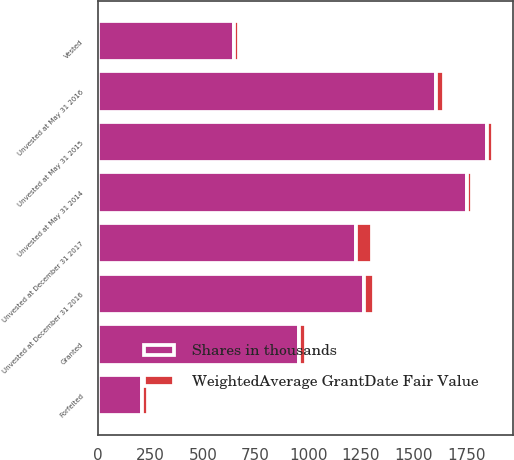Convert chart. <chart><loc_0><loc_0><loc_500><loc_500><stacked_bar_chart><ecel><fcel>Unvested at May 31 2014<fcel>Granted<fcel>Vested<fcel>Forfeited<fcel>Unvested at May 31 2015<fcel>Unvested at May 31 2016<fcel>Unvested at December 31 2016<fcel>Unvested at December 31 2017<nl><fcel>Shares in thousands<fcel>1754<fcel>954<fcel>648<fcel>212<fcel>1848<fcel>1606<fcel>1263<fcel>1226<nl><fcel>WeightedAverage GrantDate Fair Value<fcel>22.72<fcel>36.21<fcel>23.17<fcel>27.03<fcel>28.97<fcel>37.25<fcel>49.55<fcel>78.29<nl></chart> 